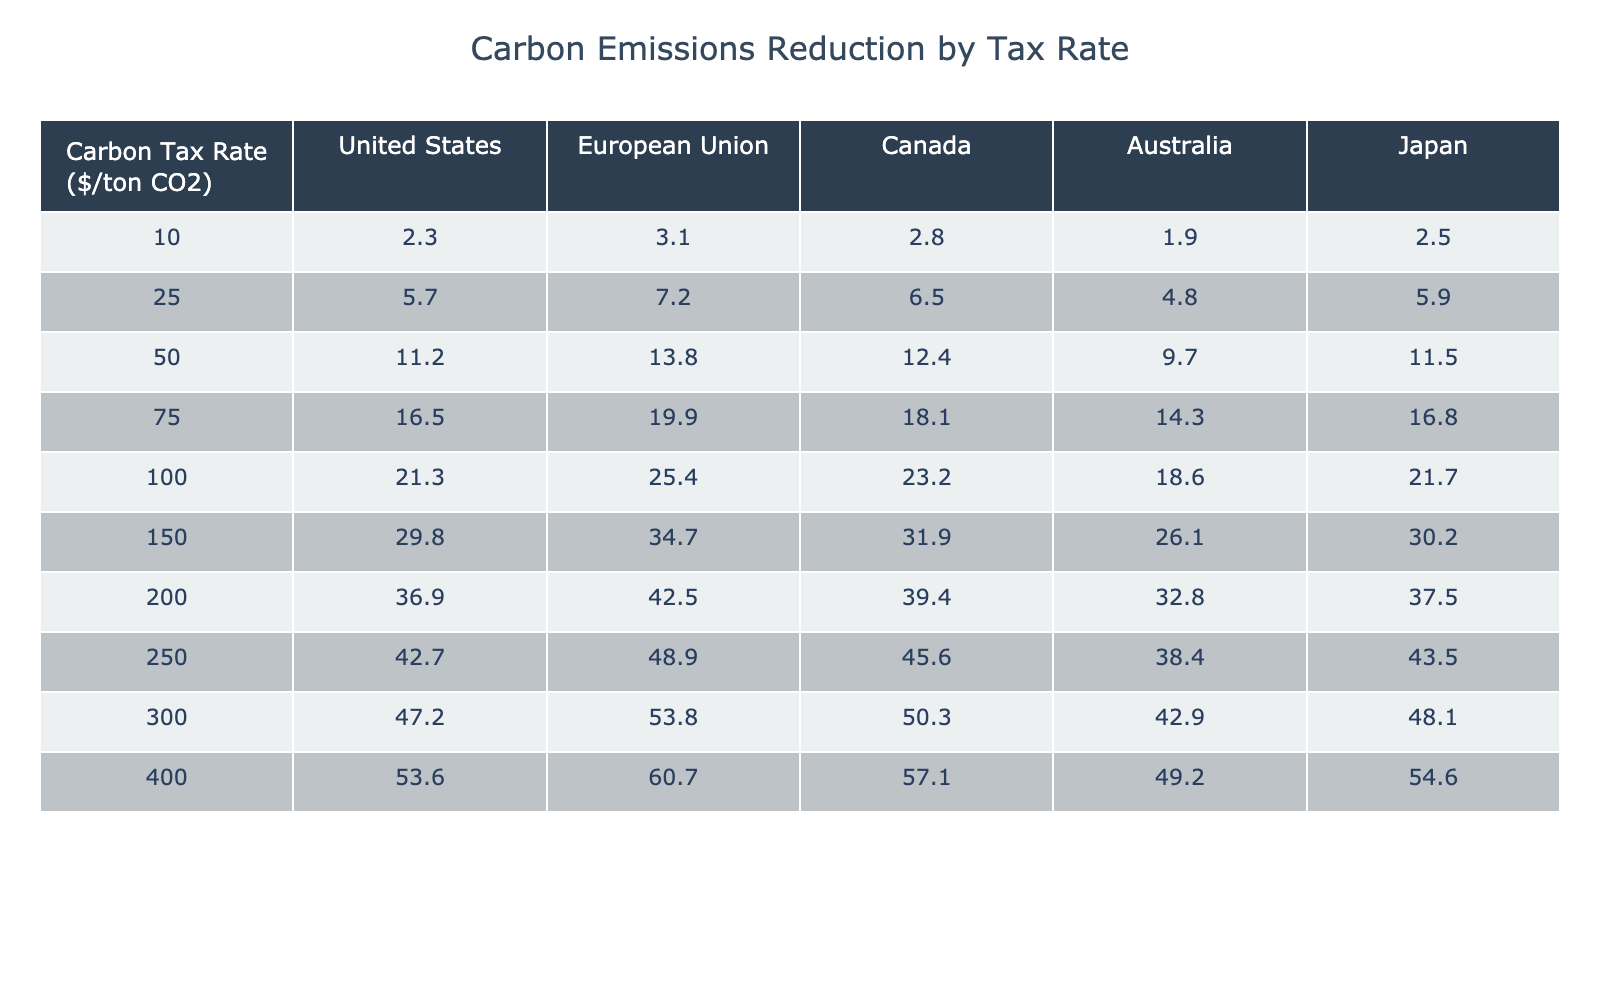What is the carbon emissions reduction achieved by a $100/ton CO2 tax rate in Canada? According to the table, under a $100/ton CO2 tax rate, the carbon emissions reduction for Canada is recorded as 23.2.
Answer: 23.2 What country has the highest carbon emissions reduction at a $150/ton CO2 tax rate? The table indicates that at a $150/ton CO2 tax rate, the European Union shows the highest reduction value of 34.7 compared to other countries listed.
Answer: European Union What is the difference in carbon emissions reduction between the United States and Australia at a $250/ton CO2 tax rate? For the $250/ton CO2 tax rate, the United States shows a reduction of 42.7 while Australia shows 38.4. The difference is calculated as 42.7 - 38.4 = 4.3.
Answer: 4.3 Average carbon emissions reduction for the European Union across all tax rates listed? The European Union values across all tax rates are: 3.1, 7.2, 13.8, 19.9, 25.4, 34.7, 42.5, 48.9, 53.8, 60.7. Adding these gives a total of 265.2 across 10 data points, leading to an average of 265.2 / 10 = 26.52.
Answer: 26.52 Is the carbon emissions reduction for Japan at a $400/ton CO2 tax rate greater than 50? Looking at the table, the reduction for Japan at this tax rate is 54.6, which is indeed greater than 50.
Answer: Yes What is the percentage increase in carbon emissions reduction for the United States from a $10/ton CO2 tax rate to a $100/ton CO2 tax rate? The reduction for the U.S. at $10/ton is 2.3 and at $100/ton is 21.3. The increase is 21.3 - 2.3 = 19.0. To find the percentage increase, (19.0 / 2.3) * 100 = 826.09%.
Answer: 826.09% Which country shows the smallest increase in carbon emissions reduction between the $75 and $100 tax rates? The increase for the United States from $75 (16.5) to $100 (21.3) is 4.8; for the EU, it’s 5.5 (25.4 - 19.9); Canada shows 5.1; Australia shows 4.3; and Japan shows 4.9. The smallest increase is seen in Australia with 4.3.
Answer: Australia What is the total carbon emissions reduction for Canada across all tax rates? Adding the values for Canada at each tax rate: 2.8 + 6.5 + 12.4 + 18.1 + 23.2 + 31.9 + 39.4 + 45.6 + 50.3 + 57.1 gives a total of 284.1.
Answer: 284.1 How does the $200 tax rate emissions reduction for the United States compare to that of Japan? United States shows 36.9 while Japan shows 37.5 at the $200 tax rate. The comparison reveals that Japan's reduction is slightly higher by 0.6.
Answer: Japan's reduction is higher by 0.6 